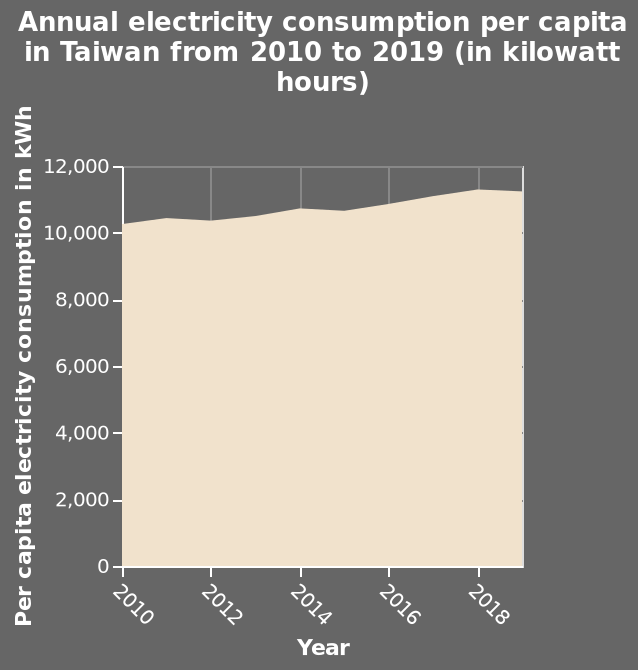<image>
What is the title of the chart?  The title of the chart is "Annual electricity consumption per capita in Taiwan from 2010 to 2019 (in kilowatt hours)". please enumerates aspects of the construction of the chart This is a area chart named Annual electricity consumption per capita in Taiwan from 2010 to 2019 (in kilowatt hours). Year is measured as a linear scale of range 2010 to 2018 along the x-axis. The y-axis shows Per capita electricity consumption in kWh. What does the y-axis show? The y-axis shows the per capita electricity consumption in kilowatt hours (kWh). What was the trend in electricity consumption in Taiwan between 2010 and 2018?  The trend in electricity consumption in Taiwan between 2010 and 2018 was a steady increase. 